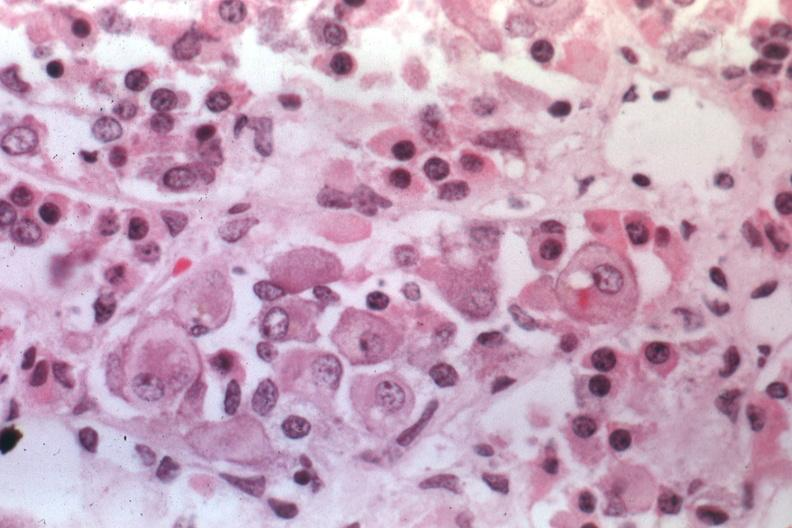s crookes cells present?
Answer the question using a single word or phrase. Yes 